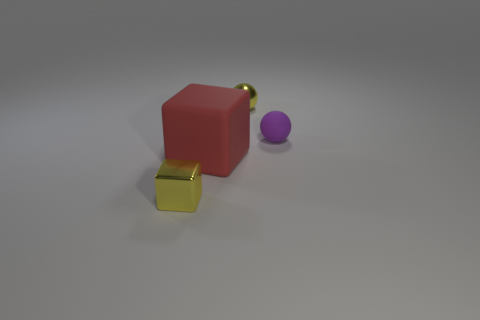Is there a sphere of the same color as the tiny metal block?
Your answer should be compact. Yes. The thing that is the same material as the tiny purple ball is what color?
Offer a terse response. Red. What number of tiny blocks are in front of the purple ball?
Make the answer very short. 1. Are the small object behind the small purple ball and the small yellow object that is left of the big rubber object made of the same material?
Your answer should be very brief. Yes. Are there more purple matte balls that are behind the big matte cube than purple rubber objects right of the tiny purple thing?
Ensure brevity in your answer.  Yes. There is a thing that is the same color as the metal cube; what is its material?
Make the answer very short. Metal. What is the material of the tiny object that is both in front of the tiny yellow metallic sphere and left of the tiny rubber ball?
Make the answer very short. Metal. Is the small cube made of the same material as the small yellow object behind the big red object?
Your response must be concise. Yes. Are there any other things that are the same size as the red thing?
Provide a succinct answer. No. How many objects are either tiny yellow metallic blocks or tiny metallic things behind the yellow metallic block?
Your answer should be very brief. 2. 